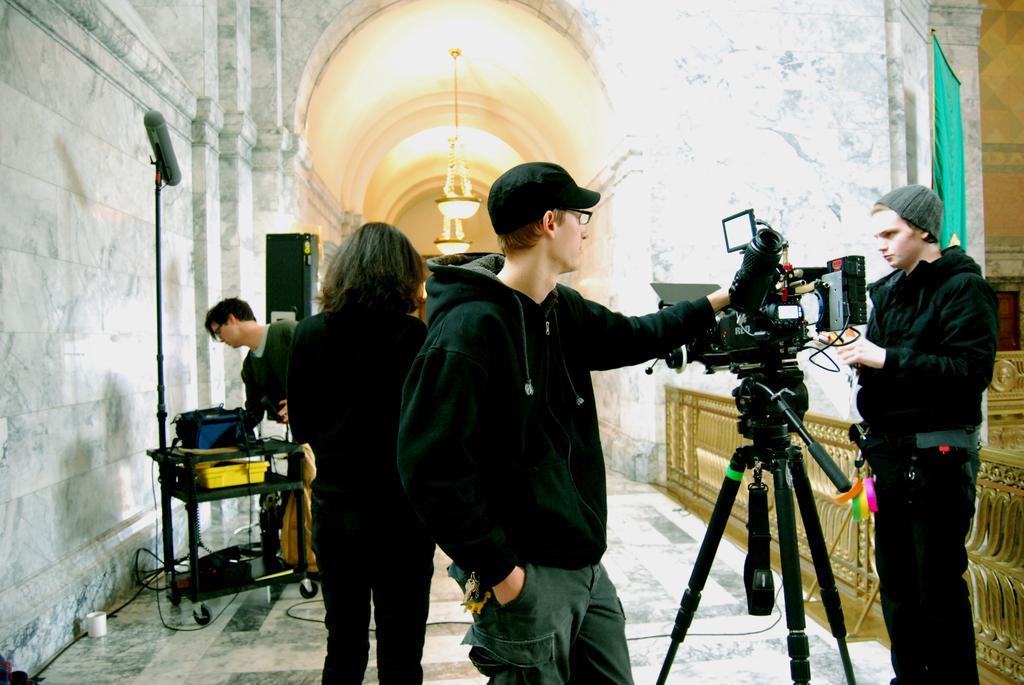Can you describe this image briefly? In this picture there are people and we can see camera with tripod, railings, green cloth, walls, objects on stand and device. We can see cable and white object on the floor. In the background of the image we can see chandeliers. 